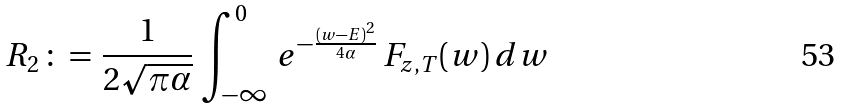Convert formula to latex. <formula><loc_0><loc_0><loc_500><loc_500>R _ { 2 } \, \colon = \, \frac { 1 } { 2 \sqrt { \pi \alpha } } \, \int _ { - \infty } ^ { 0 } \, e ^ { - \frac { ( w - E ) ^ { 2 } } { 4 \alpha } } \, F _ { z , T } ( w ) \, d w</formula> 